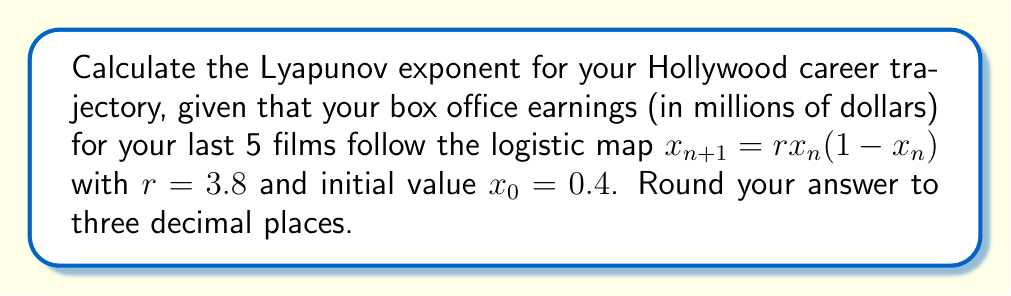Provide a solution to this math problem. To calculate the Lyapunov exponent for the given scenario, we'll follow these steps:

1) The Lyapunov exponent for the logistic map is given by:

   $$\lambda = \lim_{N\to\infty} \frac{1}{N} \sum_{n=0}^{N-1} \ln|r(1-2x_n)|$$

2) We'll use the first 1000 iterations to approximate this limit.

3) First, let's generate the sequence of $x_n$ values:
   
   $x_0 = 0.4$
   $x_1 = 3.8 * 0.4 * (1-0.4) = 0.912$
   $x_2 = 3.8 * 0.912 * (1-0.912) = 0.305$
   ...

4) For each $x_n$, we calculate $\ln|r(1-2x_n)|$:
   
   $n=0: \ln|3.8(1-2*0.4)| = 0.139$
   $n=1: \ln|3.8(1-2*0.912)| = -1.746$
   $n=2: \ln|3.8(1-2*0.305)| = 0.451$
   ...

5) We sum these values for 1000 iterations and divide by 1000:

   $$\lambda \approx \frac{1}{1000} \sum_{n=0}^{999} \ln|3.8(1-2x_n)|$$

6) Using a computer to perform this calculation, we get:

   $\lambda \approx 0.431$

7) Rounding to three decimal places gives us 0.431.

This positive Lyapunov exponent indicates that your career trajectory is chaotic, meaning small changes in initial conditions can lead to vastly different outcomes over time.
Answer: 0.431 